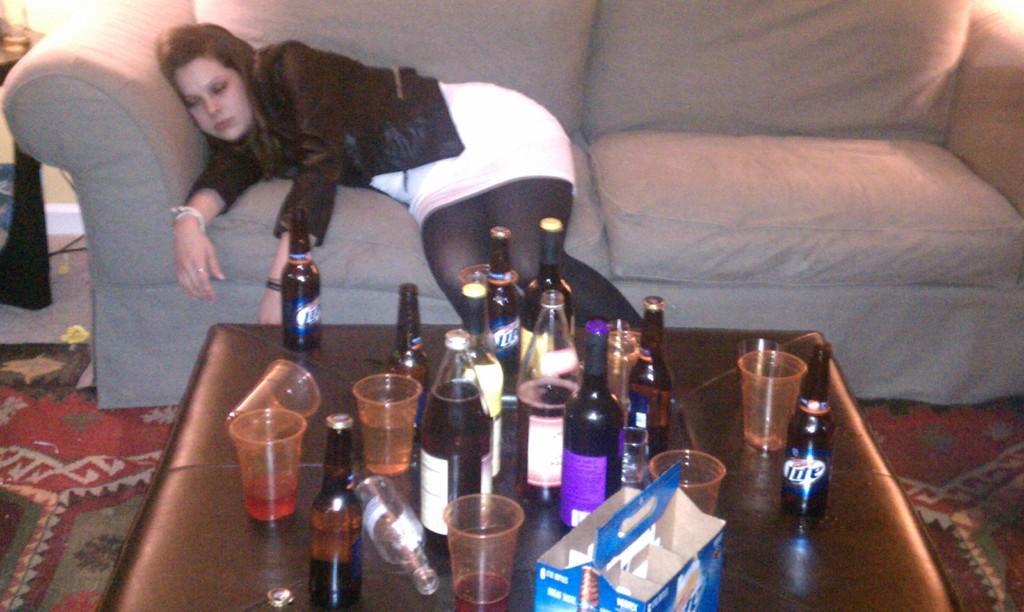Please provide a concise description of this image. In this image i can see a woman laying on a couch there are few bottles, glasses, box on a table. 